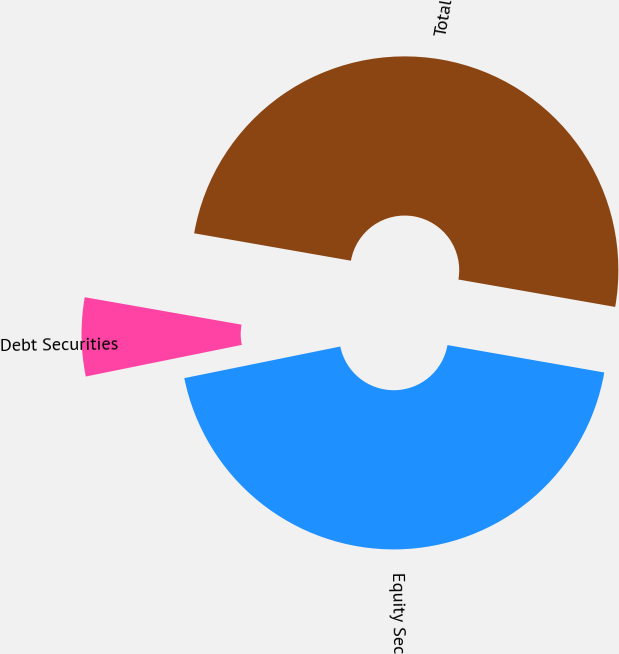Convert chart to OTSL. <chart><loc_0><loc_0><loc_500><loc_500><pie_chart><fcel>Equity Securities<fcel>Debt Securities<fcel>Total<nl><fcel>44.06%<fcel>5.94%<fcel>50.0%<nl></chart> 